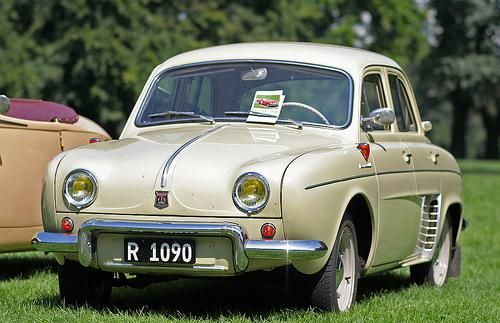Can you guess the era this car was manufactured? Based on the styling and overall design, the car appears to be from the 1950s or 1960s. 